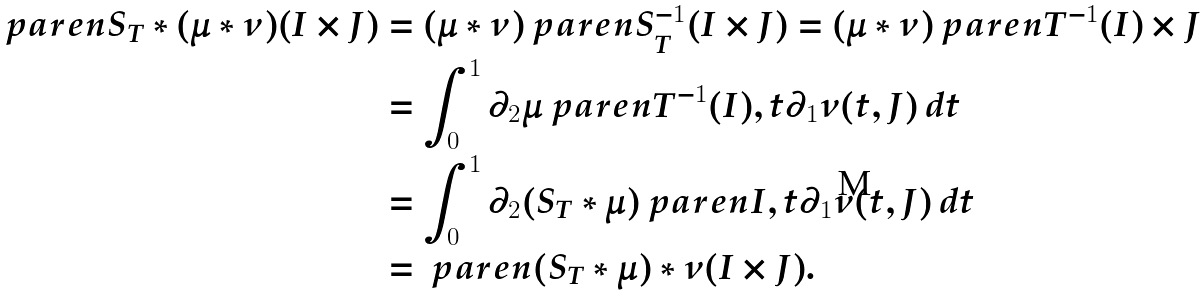Convert formula to latex. <formula><loc_0><loc_0><loc_500><loc_500>\ p a r e n { S _ { T } * ( \mu * \nu ) } ( I \times J ) & = ( \mu * \nu ) \ p a r e n { S _ { T } ^ { - 1 } ( I \times J ) } = ( \mu * \nu ) \ p a r e n { T ^ { - 1 } ( I ) \times J } \\ & = \int _ { 0 } ^ { 1 } \partial _ { 2 } \mu \ p a r e n { T ^ { - 1 } ( I ) , t } \partial _ { 1 } \nu ( t , J ) \, d t \\ & = \int _ { 0 } ^ { 1 } \partial _ { 2 } ( S _ { T } * \mu ) \ p a r e n { I , t } \partial _ { 1 } \nu ( t , J ) \, d t \\ & = \ p a r e n { ( S _ { T } * \mu ) * \nu } ( I \times J ) .</formula> 